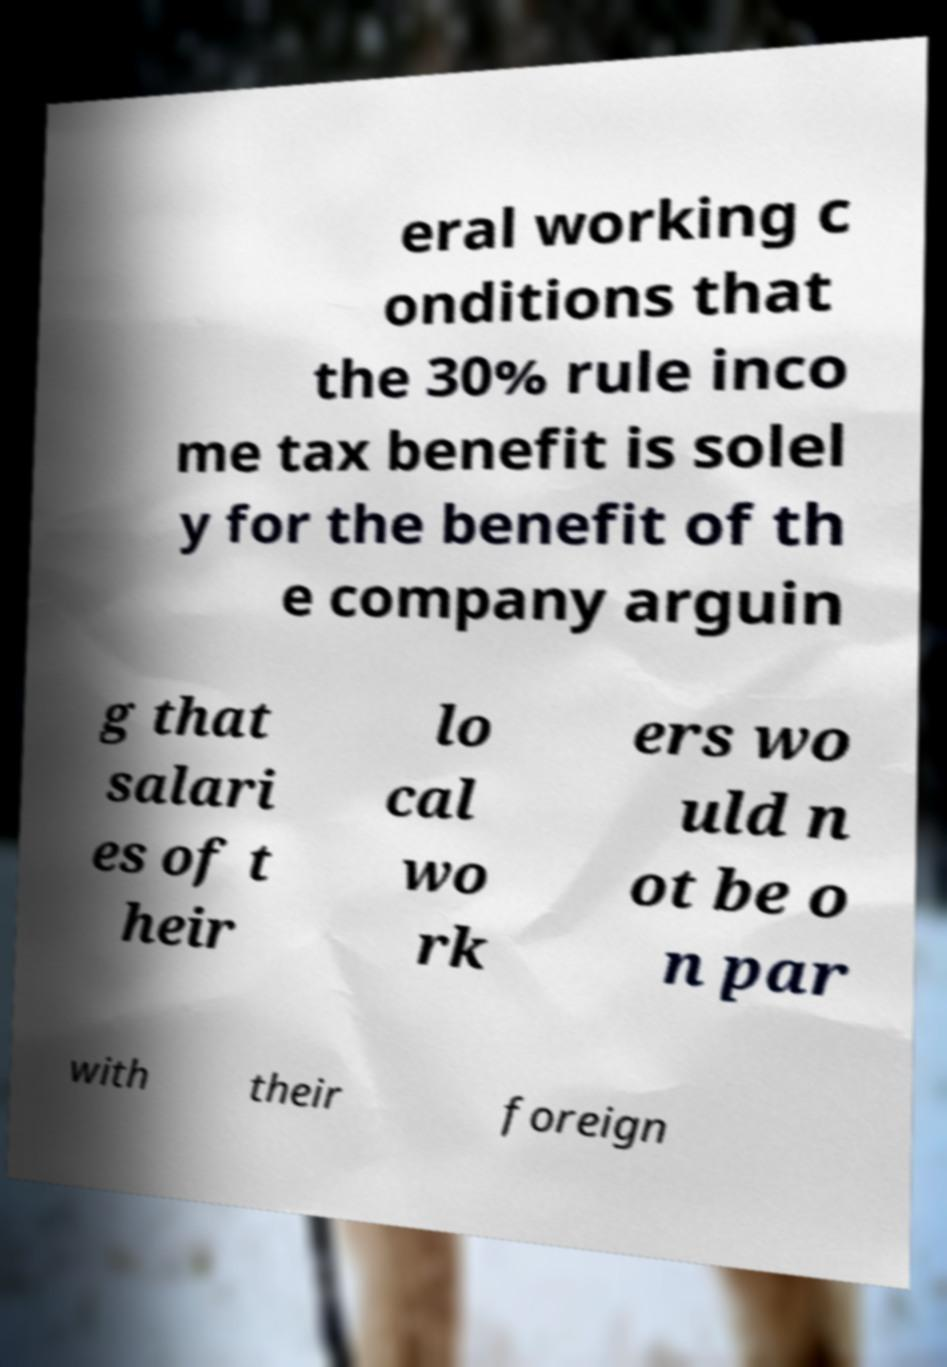Can you accurately transcribe the text from the provided image for me? eral working c onditions that the 30% rule inco me tax benefit is solel y for the benefit of th e company arguin g that salari es of t heir lo cal wo rk ers wo uld n ot be o n par with their foreign 